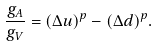Convert formula to latex. <formula><loc_0><loc_0><loc_500><loc_500>\frac { g _ { A } } { g _ { V } } = ( \Delta u ) ^ { p } - ( \Delta d ) ^ { p } .</formula> 